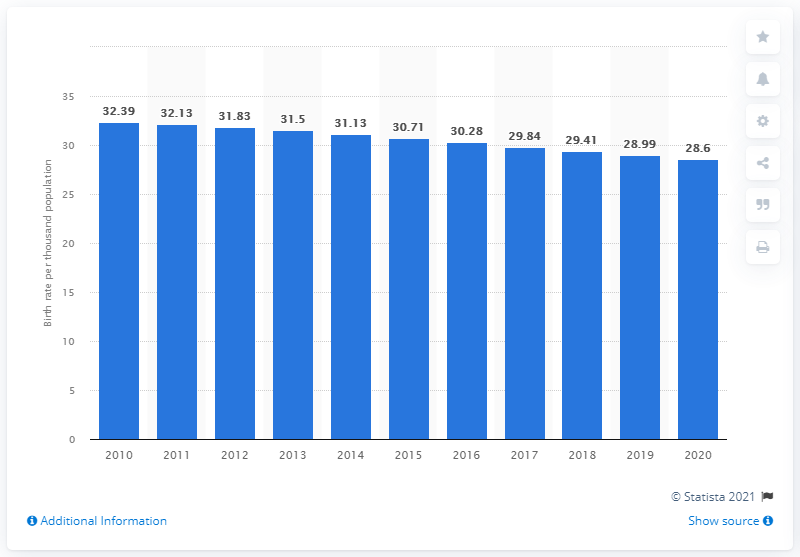Draw attention to some important aspects in this diagram. In 2020, the crude birth rate in Ghana was 28.6 per 1,000 population, indicating a slight decrease from the previous year. 